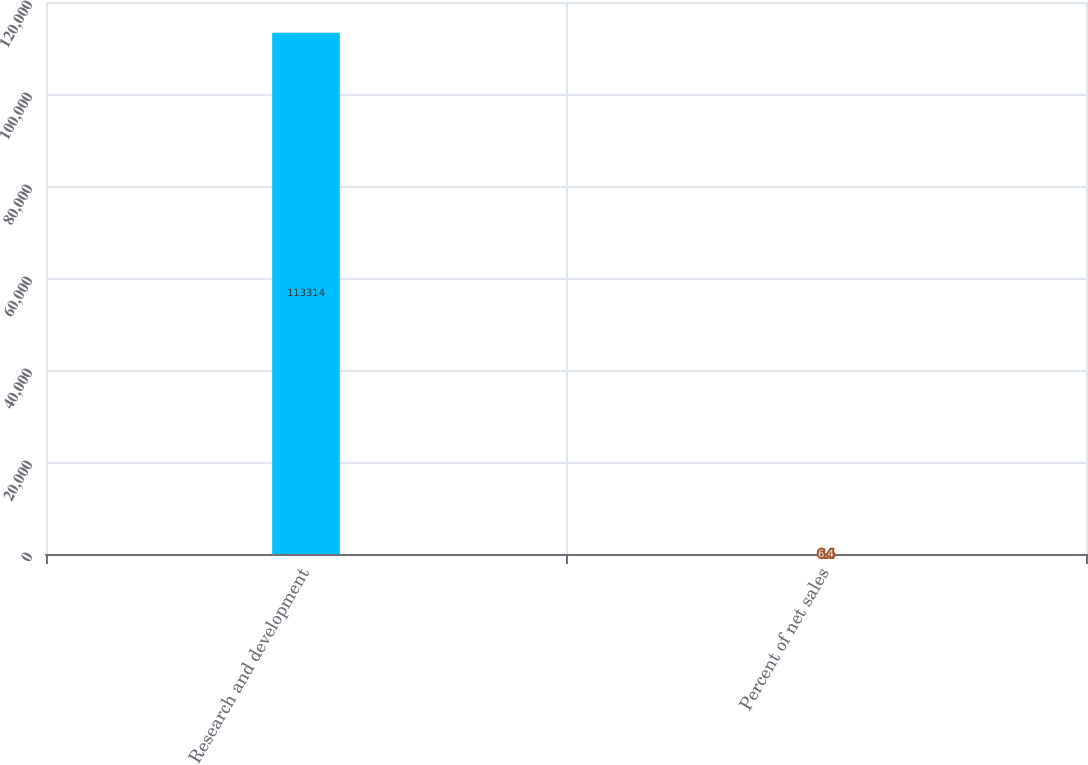Convert chart. <chart><loc_0><loc_0><loc_500><loc_500><bar_chart><fcel>Research and development<fcel>Percent of net sales<nl><fcel>113314<fcel>6.4<nl></chart> 